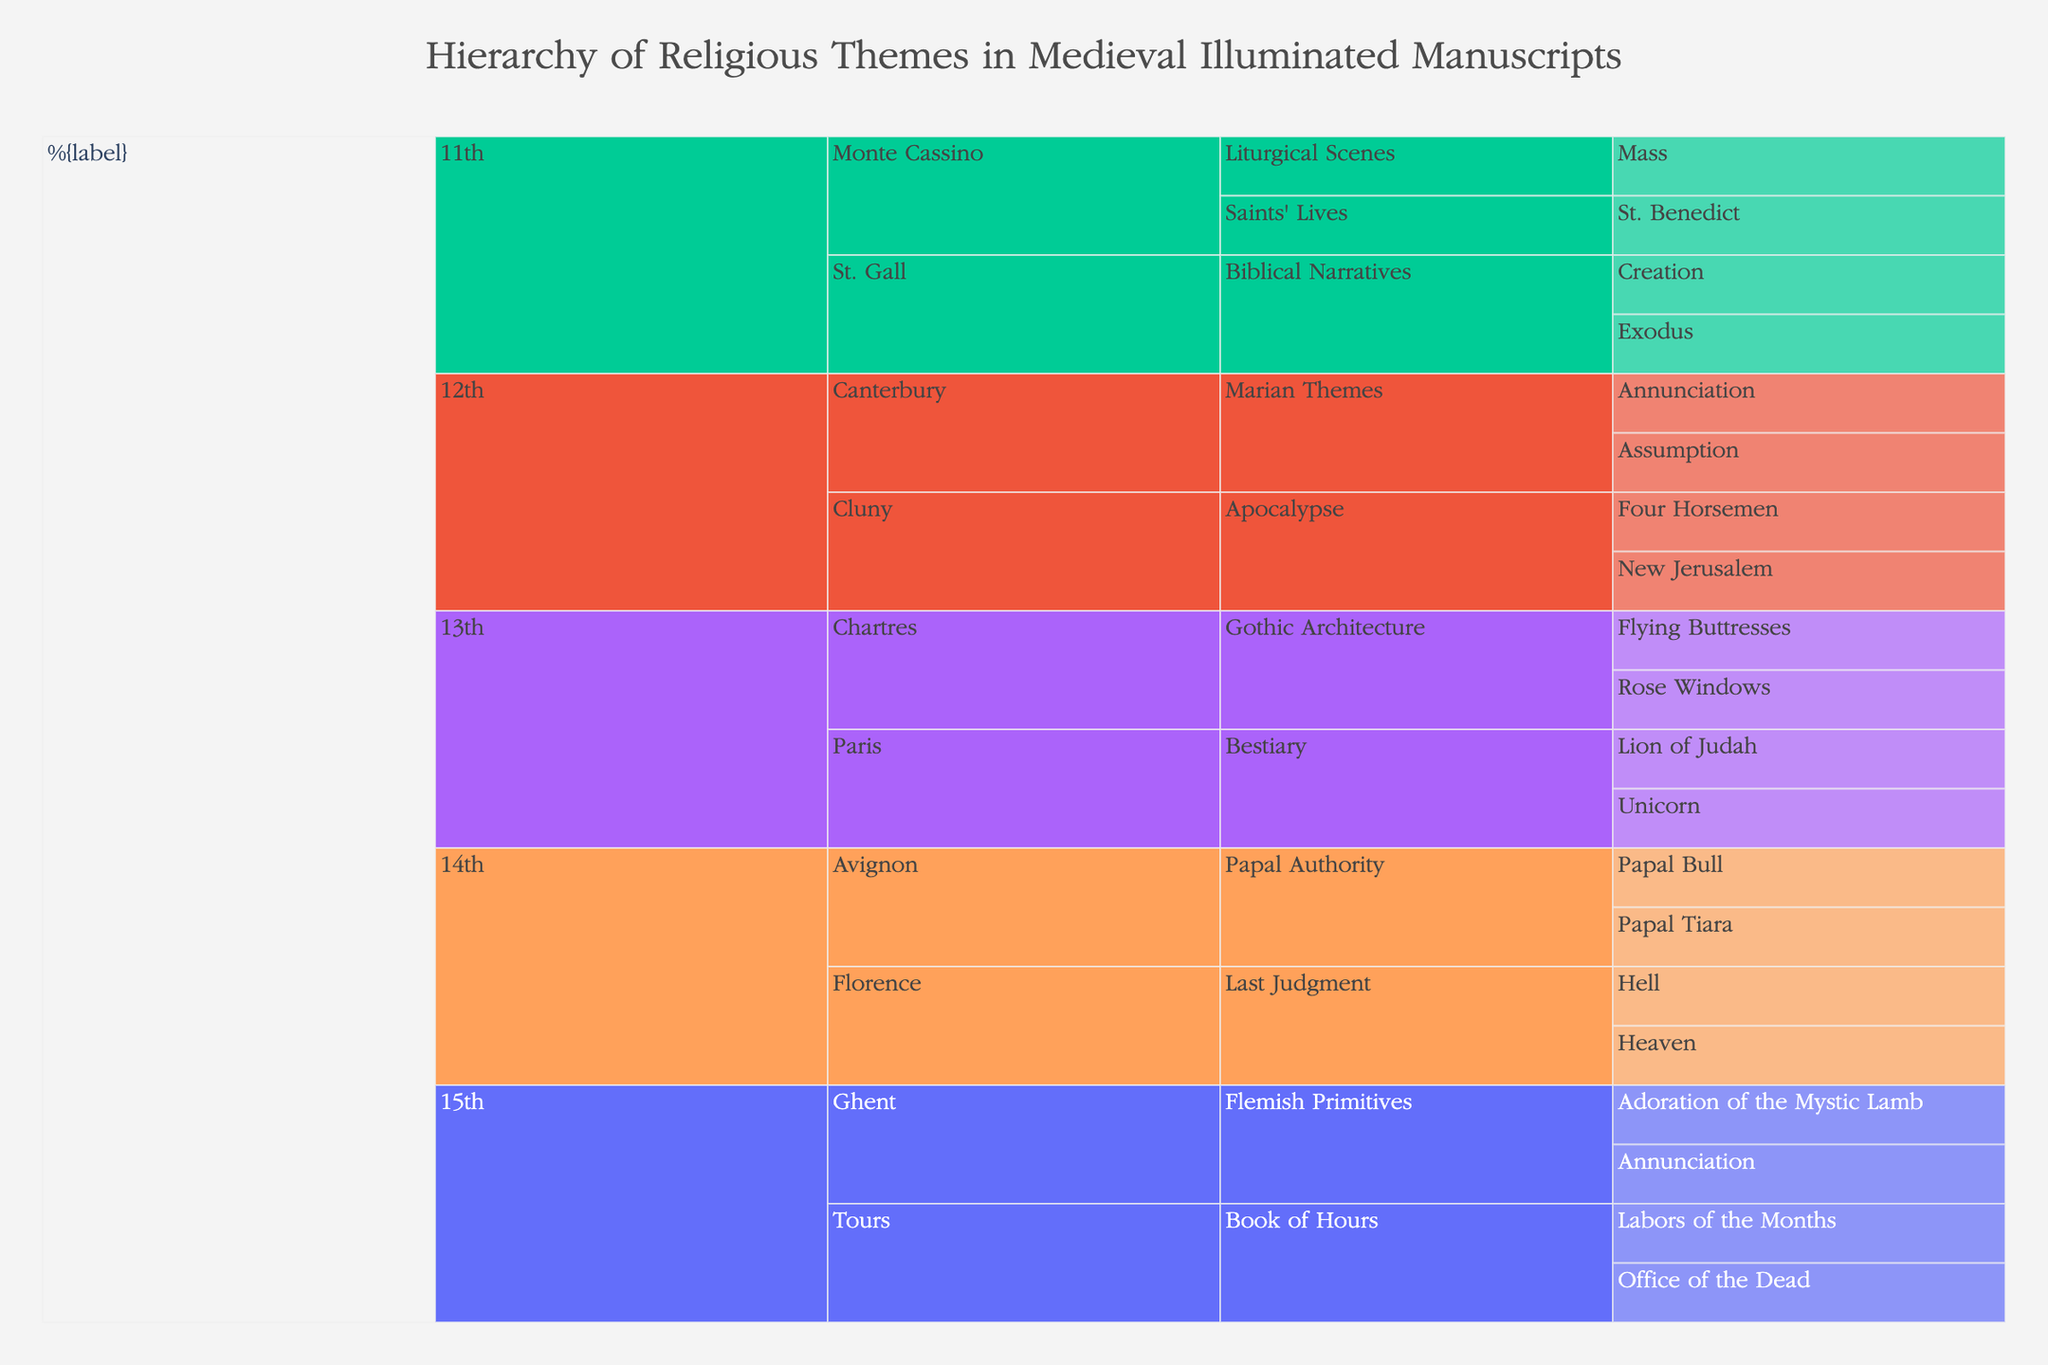What's the earliest century shown in the chart? The chart categorizes themes by century, starting with the 11th century. This is the earliest century displayed.
Answer: 11th century How many scriptoria are represented within the 12th century? Within the 12th century section of the chart, two scriptoria are depicted: Cluny and Canterbury.
Answer: 2 Which century features themes from the Flemish Primitives? By looking at the plot, the Flemish Primitives theme is shown under the 15th century.
Answer: 15th century Between St. Gall and Monte Cassino in the 11th century, which scriptoria has a theme related to Biblical Narratives? St. Gall within the 11th century has Biblical Narratives under its themes, whereas Monte Cassino does not.
Answer: St. Gall How many subthemes are under the Last Judgment theme in the 14th century? The Last Judgment theme in the 14th century has two subthemes: Heaven and Hell.
Answer: 2 Which century has the most diverse themes in the chart? By examining the chart, the 15th century contains themes from two scriptoria (Ghent and Tours) and features two themes: Flemish Primitives and Book of Hours.
Answer: 15th century What are the Marian Themes subthemes in the 12th century? In the 12th century, under Marian Themes, there are two subthemes: Annunciation and Assumption.
Answer: Annunciation and Assumption How many distinct themes are represented in the Monte Cassino scriptorium in the 11th century? Monte Cassino in the 11th century has two distinct themes: Saints' Lives and Liturgical Scenes.
Answer: 2 Which scriptoria in the 13th century depict Gothic Architecture? In the 13th century, Chartres is the scriptorium depicting the Gothic Architecture theme.
Answer: Chartres Is there a theme depicted in both the 11th and 12th centuries? Comparing themes across the 11th and 12th centuries, none of the themes overlap (Biblical Narratives, Saints' Lives, Liturgical Scenes in the 11th; Apocalypse, Marian Themes in the 12th).
Answer: No 